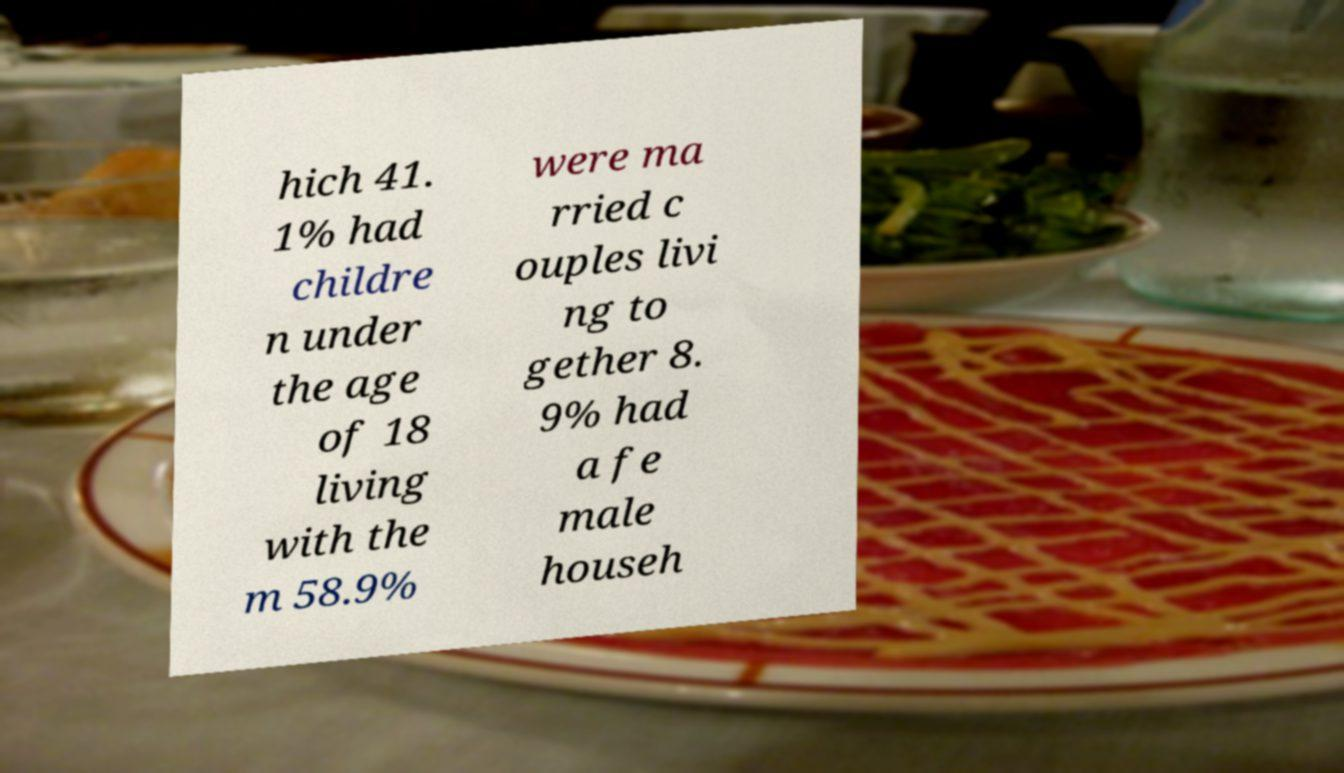Please read and relay the text visible in this image. What does it say? hich 41. 1% had childre n under the age of 18 living with the m 58.9% were ma rried c ouples livi ng to gether 8. 9% had a fe male househ 